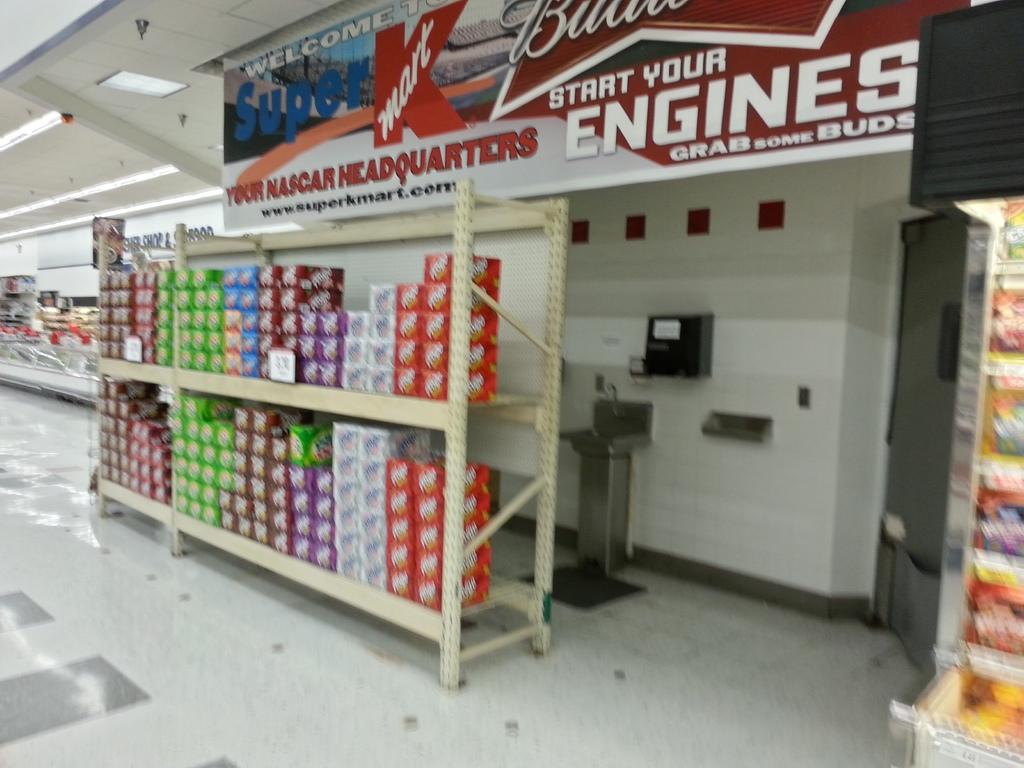<image>
Summarize the visual content of the image. A super K Mart banner above various kins of pop on a shelf. 